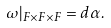Convert formula to latex. <formula><loc_0><loc_0><loc_500><loc_500>\omega | _ { F \times F \times F } = d \alpha .</formula> 